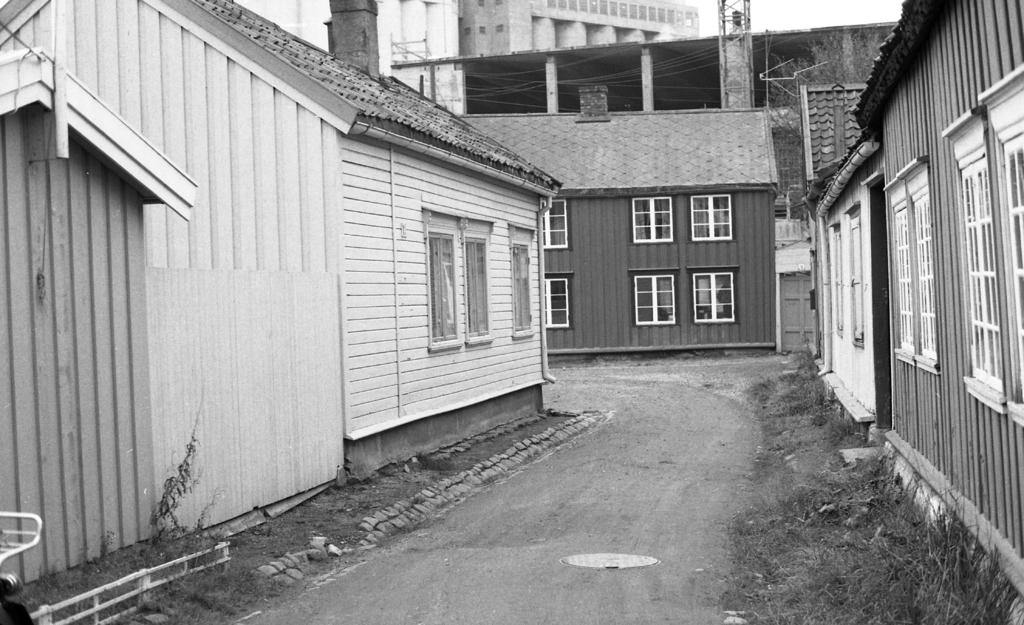What is the main feature of the image? There is a road in the image. What can be seen on both sides of the road? There are buildings on both sides of the road. What type of windows do the buildings have? The buildings have glass windows. What type of vegetation is visible in the image? There is grass visible in the image. What can be seen in the background of the image? There are buildings and the sky visible in the background of the image. What type of instrument is being played by the army in the image? There is no army or instrument present in the image. 